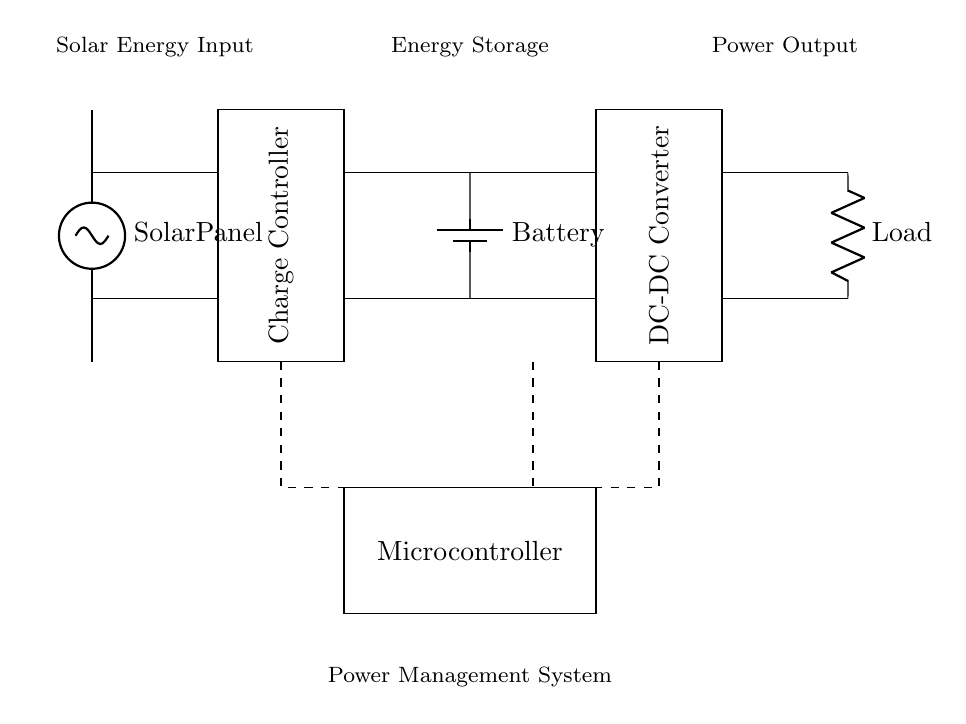What is the component that receives energy from solar panels? The solar panel is located at the top left of the circuit, labeled simply as "Solar Panel". It converts sunlight into electrical energy, which is the first stage of energy input in this system.
Answer: Solar Panel What is the function of the charge controller in this circuit? The charge controller is a rectangular block positioned centrally in the circuit, it is designed to manage the voltage and current coming from the solar panels to the battery, ensuring the battery is charged optimally without overcharging.
Answer: Charging management How many main components are connected to the battery? The battery is directly connected to the charge controller on the left side and the DC-DC converter on the right side. This gives a total of two components connected to the battery.
Answer: Two What does the load represent in this circuit? The load in this circuit is represented by a resistor labeled as "Load". It is the component that consumes the electrical energy provided by the battery through the DC-DC converter, indicating where the power output is utilized.
Answer: Power consumer What is the purpose of the microcontroller in this power management circuit? The microcontroller, depicted at the bottom center of the circuit diagram, serves as the control unit to manage and optimize the operations of the charge controller and DC-DC converter. It regulates the system's performance and battery management, ensuring efficient energy usage.
Answer: Control unit What type of converter is shown in this circuit? The circuit includes a DC-DC converter located on the right side, which adjusts the voltage levels of the energy output from the battery before supplying it to the load. This converter ensures that the load receives the required voltage and current for proper function.
Answer: DC-DC Converter How does the framework of this power management circuit facilitate energy coordination? The arrangement of components, including the solar panel, charge controller, battery, DC-DC converter, and microcontroller, creates an efficient flow of energy. Solar energy is captured, regulated, stored, and converted appropriately, allowing continuous power supply to remote locations, optimizing usage of available resources.
Answer: Energy optimization 